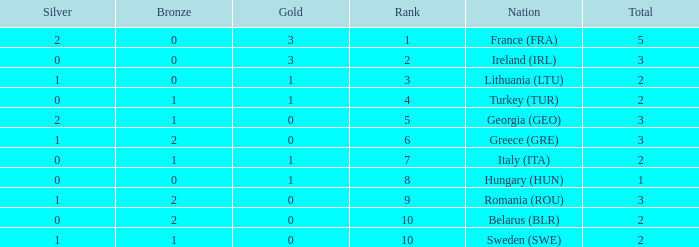What's the total of rank 8 when Silver medals are 0 and gold is more than 1? 0.0. 